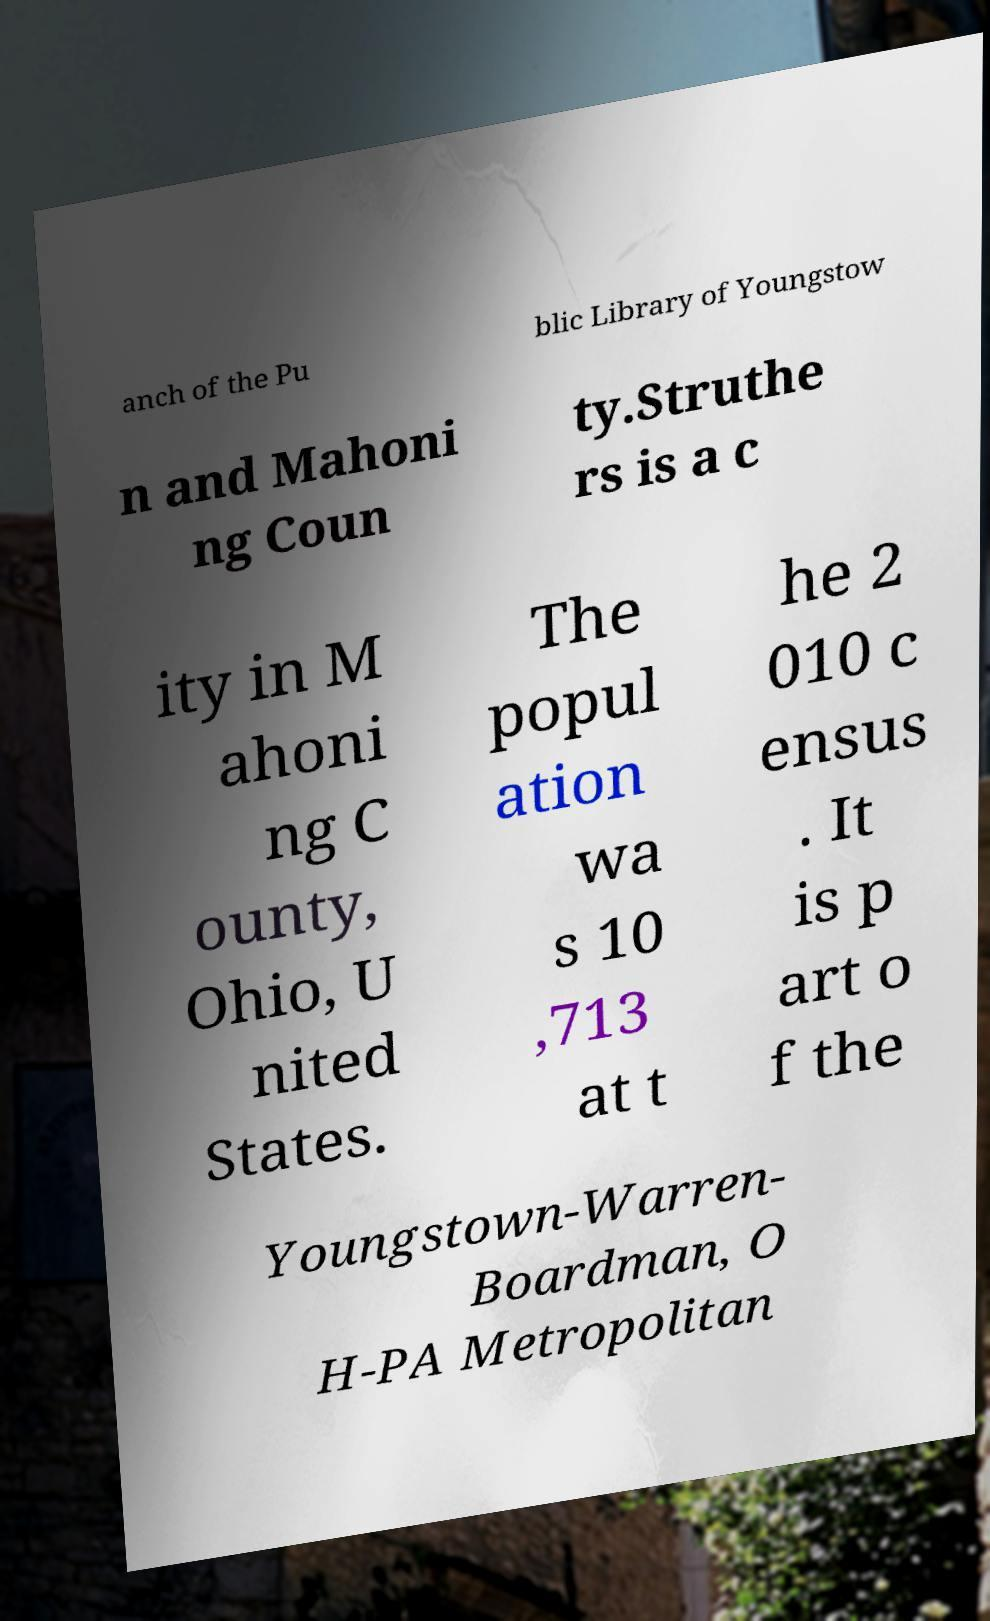There's text embedded in this image that I need extracted. Can you transcribe it verbatim? anch of the Pu blic Library of Youngstow n and Mahoni ng Coun ty.Struthe rs is a c ity in M ahoni ng C ounty, Ohio, U nited States. The popul ation wa s 10 ,713 at t he 2 010 c ensus . It is p art o f the Youngstown-Warren- Boardman, O H-PA Metropolitan 